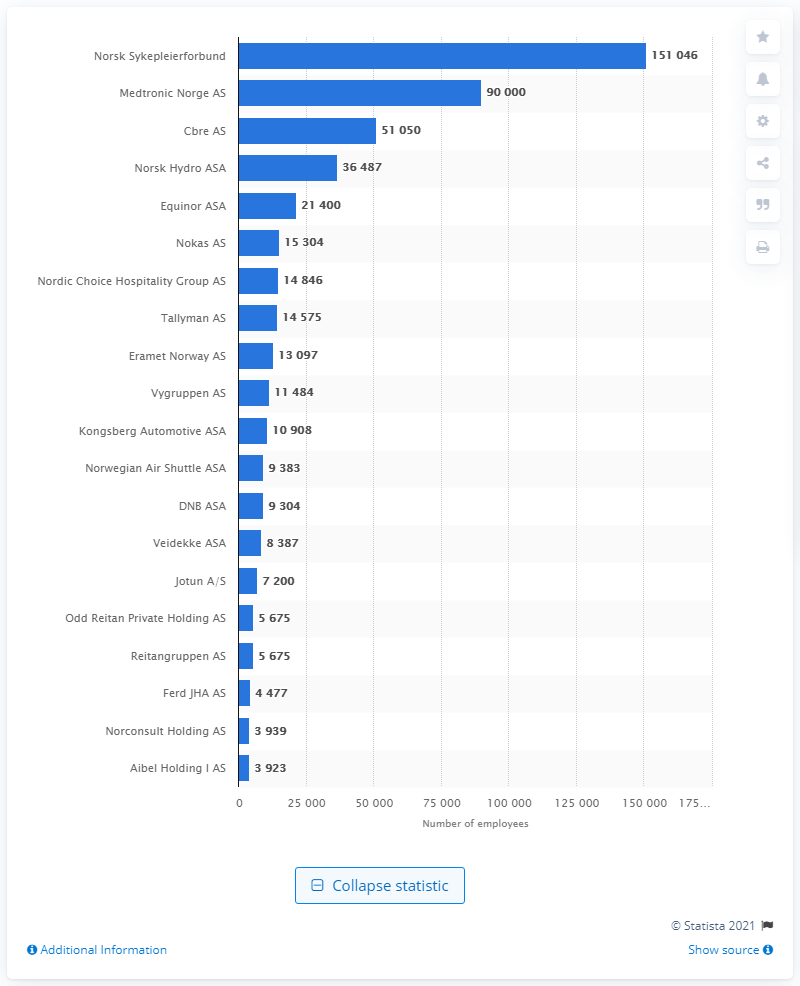Mention a couple of crucial points in this snapshot. Medtronic Norge AS has the most employees in Norway. Norsk Sykepleierforbund has the most employees among all companies in Norway. 